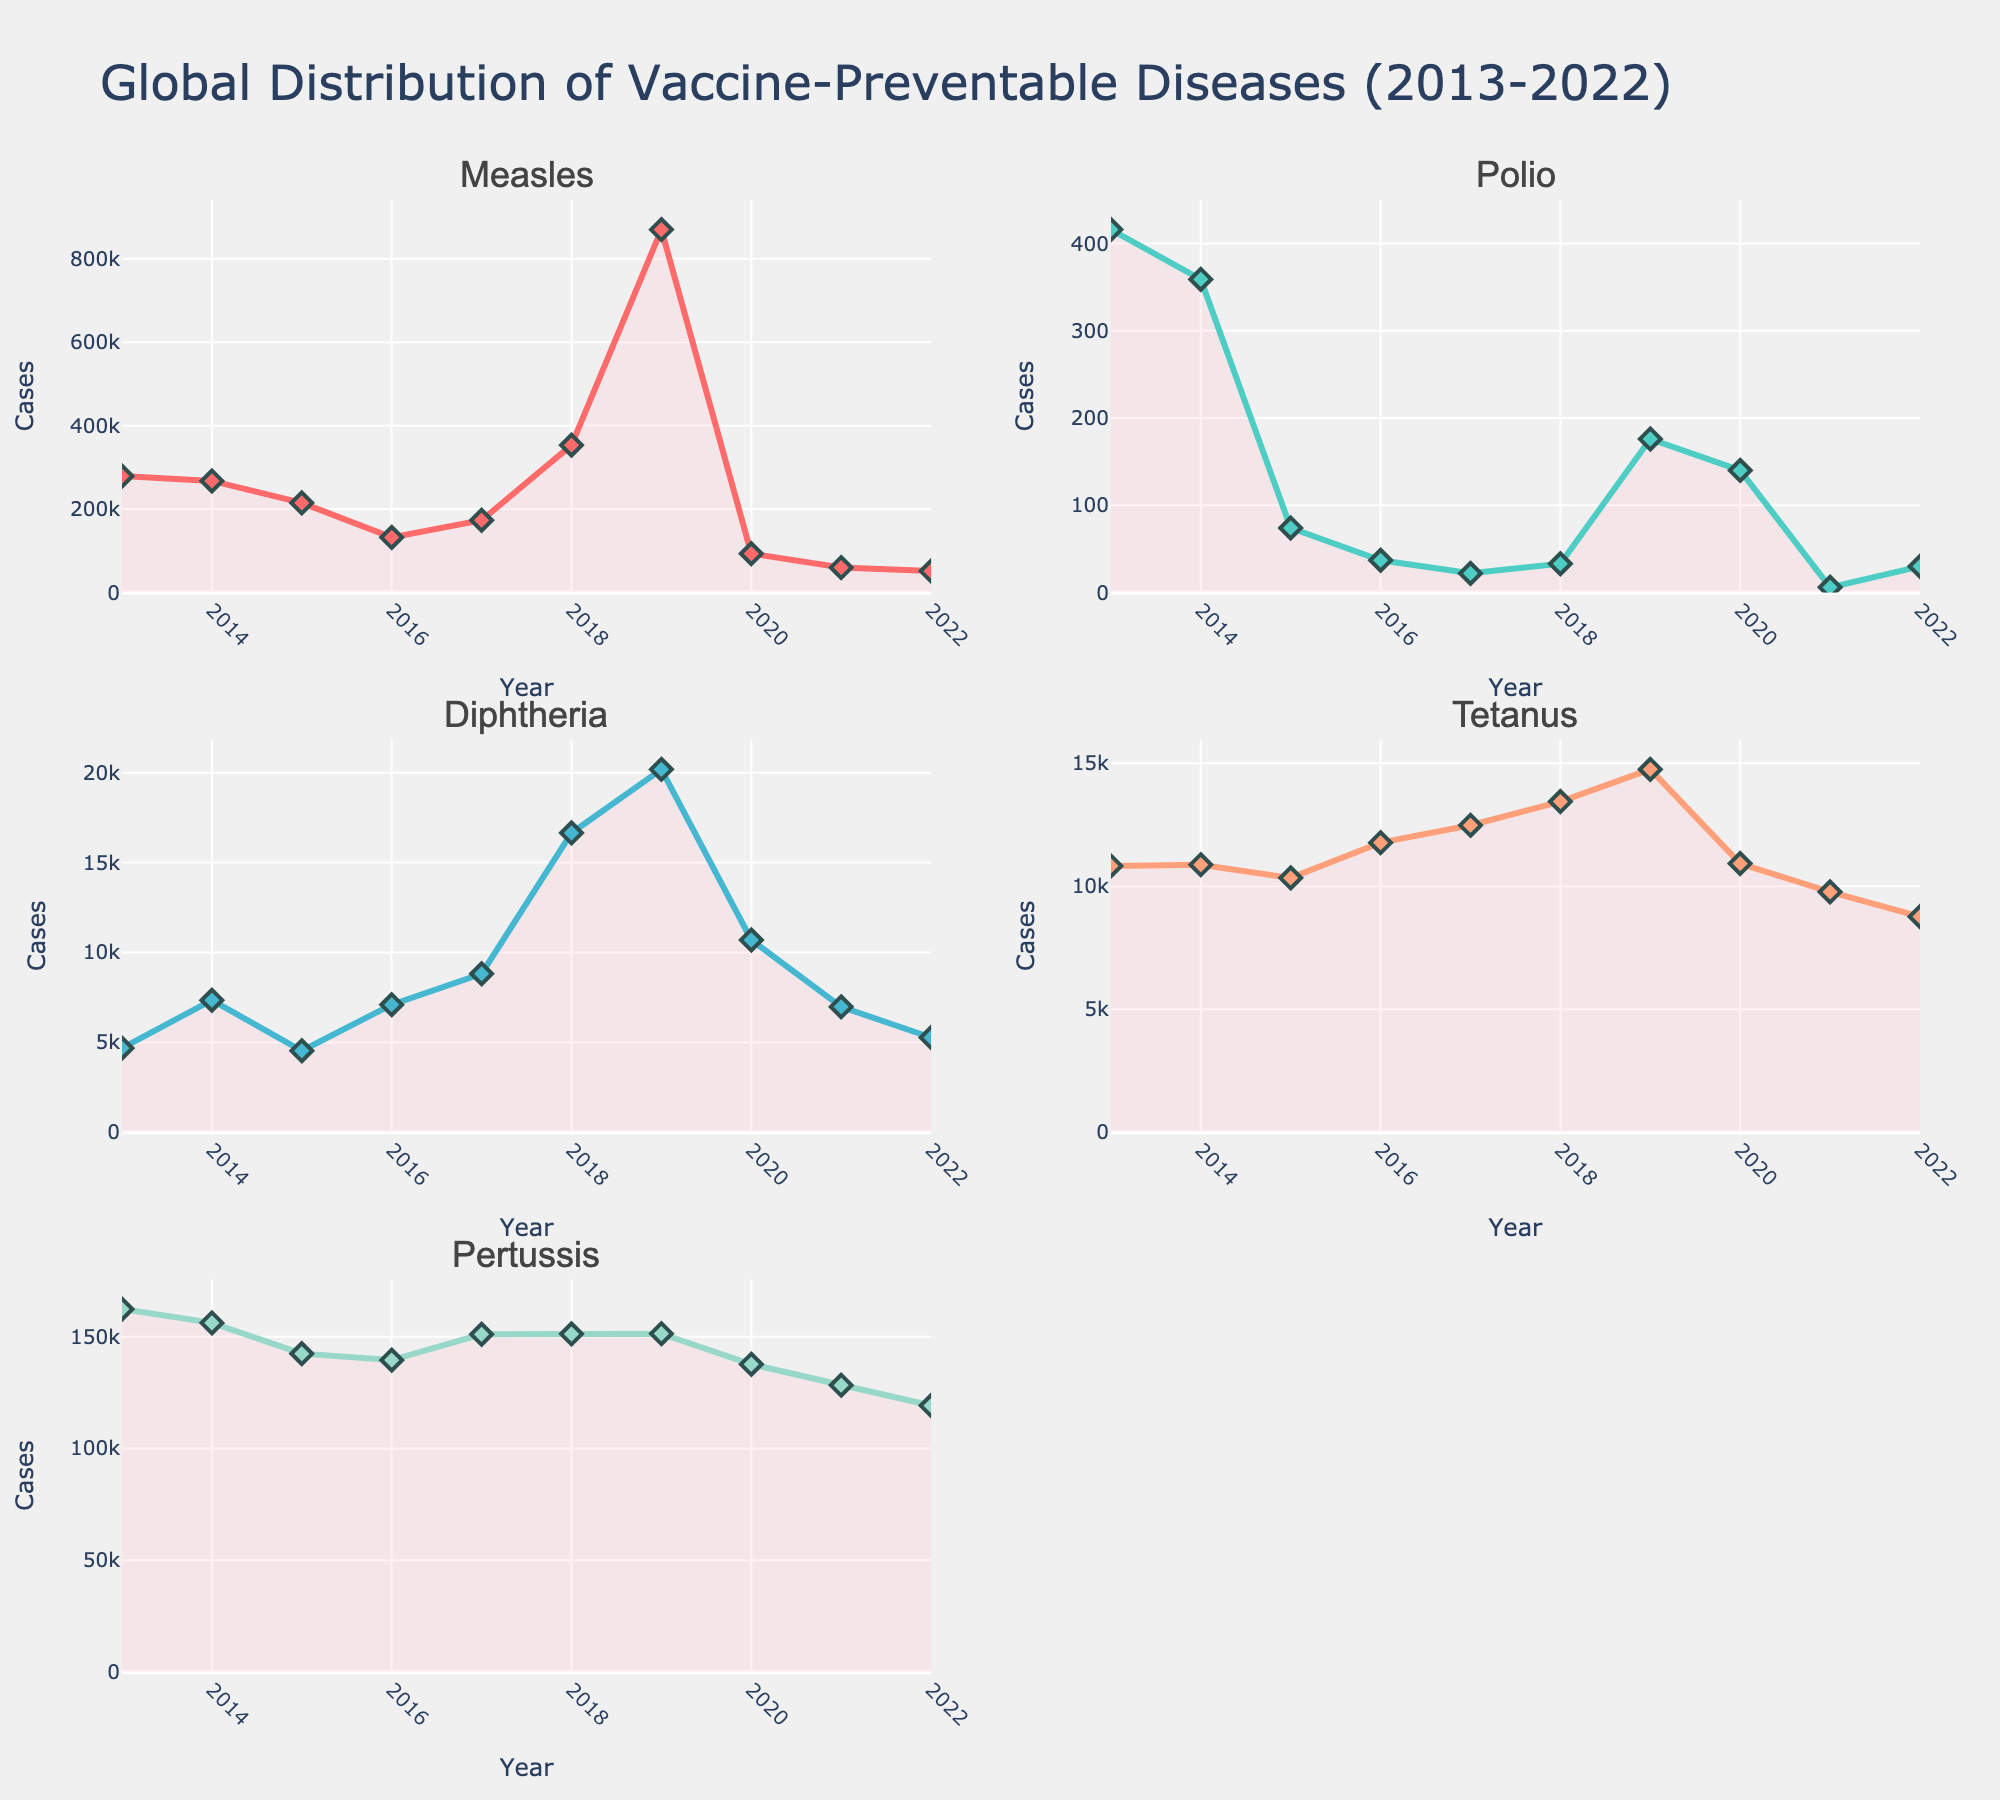What is the title of the figure? The title is located at the top center of the figure and describes the overall content. The title of this figure is "Global Distribution of Vaccine-Preventable Diseases (2013-2022)"
Answer: Global Distribution of Vaccine-Preventable Diseases (2013-2022) Which disease had the lowest number of cases in 2013? To determine this, look at the plots for all diseases for the year 2013. From the plots, it is clear that Polio had the lowest number of cases in 2013.
Answer: Polio How many diseases are shown in the subplots? Count the number of individual subplot titles. There are five subplot titles, each representing a different disease.
Answer: Five Which year shows the highest number of Measles cases? To find this, look at the plot for Measles and identify the year with the highest point. It is 2019, where the cases reach 869,770.
Answer: 2019 Between which years did Diphtheria cases show the greatest reduction? Look at the Diphtheria subplot and find the steepest decline. The cases dropped significantly from 2019 to 2020 (20,188 to 10,695).
Answer: 2019 to 2020 Compare the trends of Measles and Polio from 2013 to 2022? From 2013 to 2022, Measles shows a fluctuating trend with peaks and drops, peaking in 2019. Polio cases have been steadily decreasing except for a slight increase around 2019 and 2020.
Answer: Measles fluctuates; Polio decreases overall with minor increases around 2019-2020 Which disease showed the highest number of cases in 2022, and how many cases were reported? Look at the endpoints of each subplot for the year 2022. Measles had the highest number of cases with 51,465 reported.
Answer: Measles with 51,465 cases Is there any year where all diseases show a decrease in cases compared to the previous year? Inspect each subplot for simultaneous declines across all diseases. From 2019 to 2020, every disease shows a decrease in their reported cases.
Answer: Yes, from 2019 to 2020 How do Tetanus cases in 2022 compare to Tetanus cases in 2013? Look at the start and end points of the Tetanus subplot. Tetanus cases decreased from 10,825 in 2013 to 8,764 in 2022.
Answer: Decreased Which disease shows the most volatile trend over the years? Volatile trends are characterized by large fluctuations. Measles has the most volatile trend, with varying peaks and troughs, especially the significant peak in 2019.
Answer: Measles 